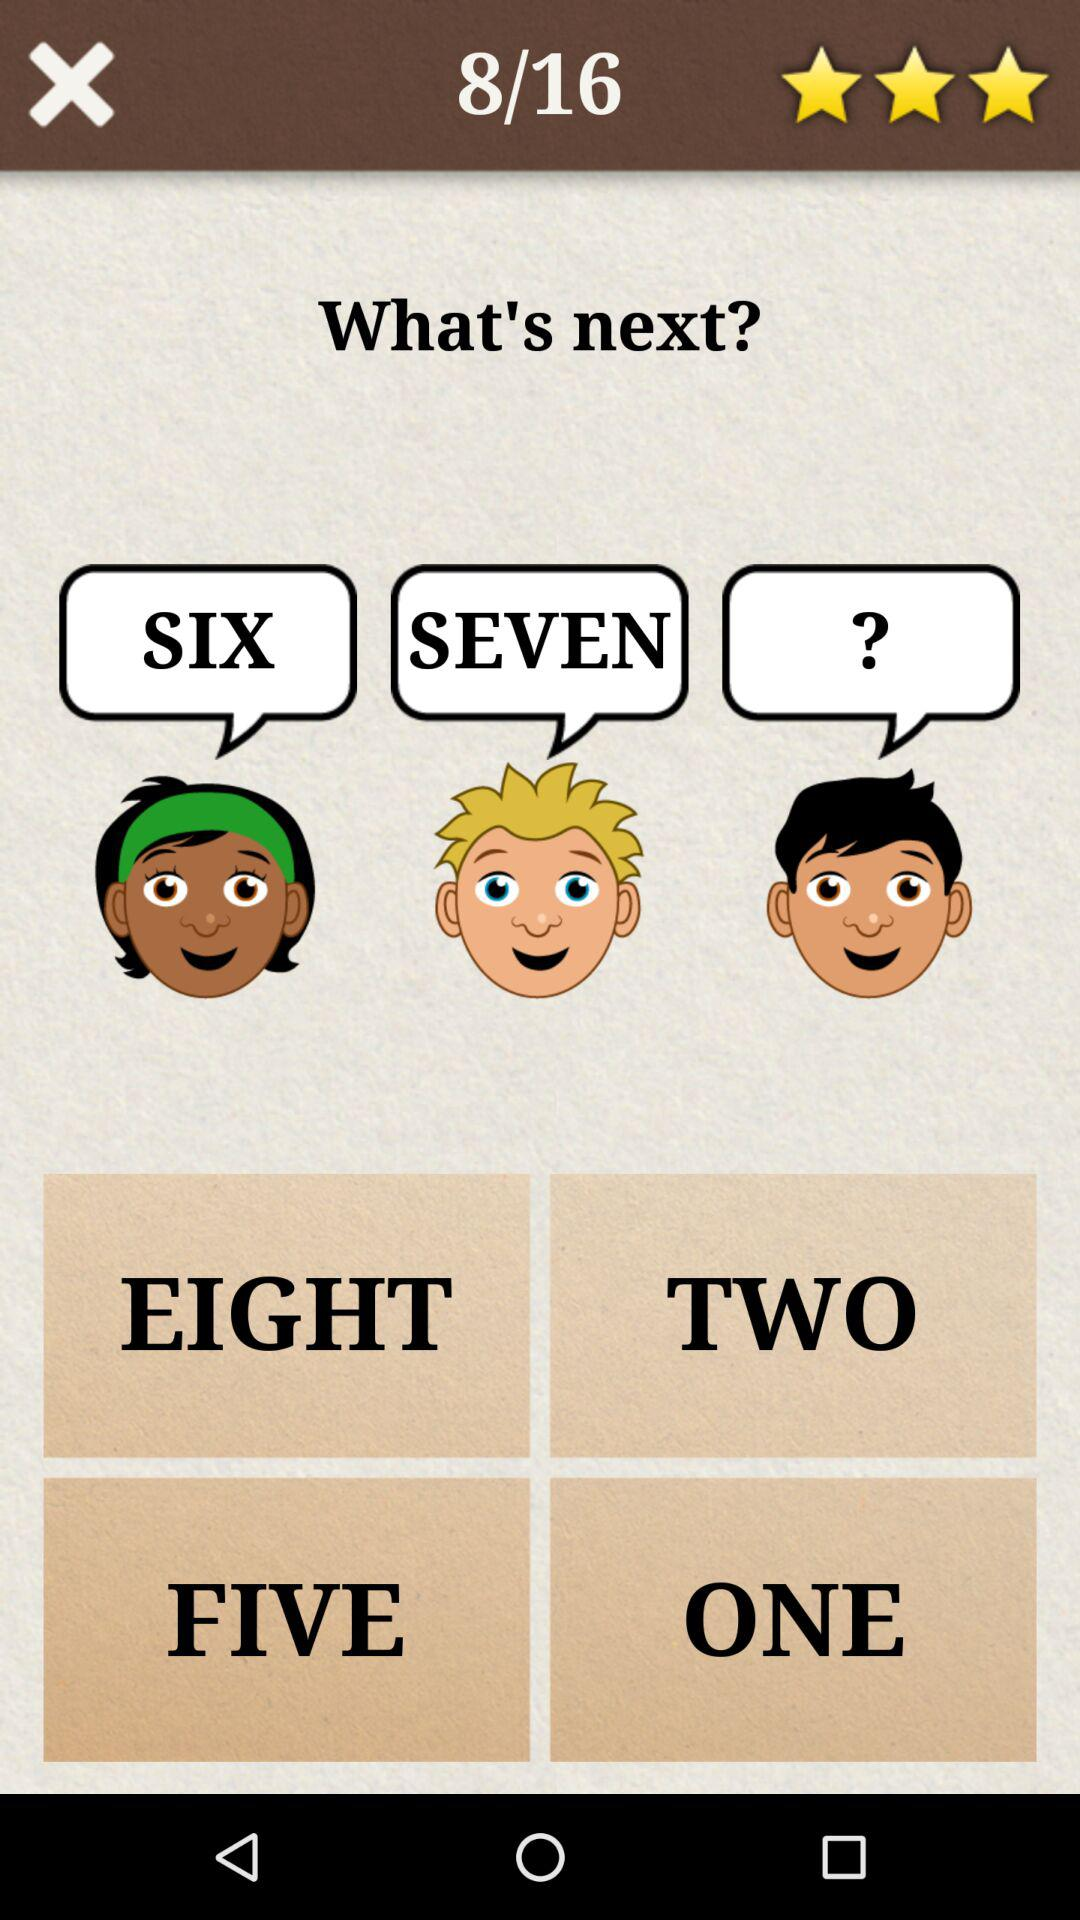How many stars are there? There are 3 stars. 